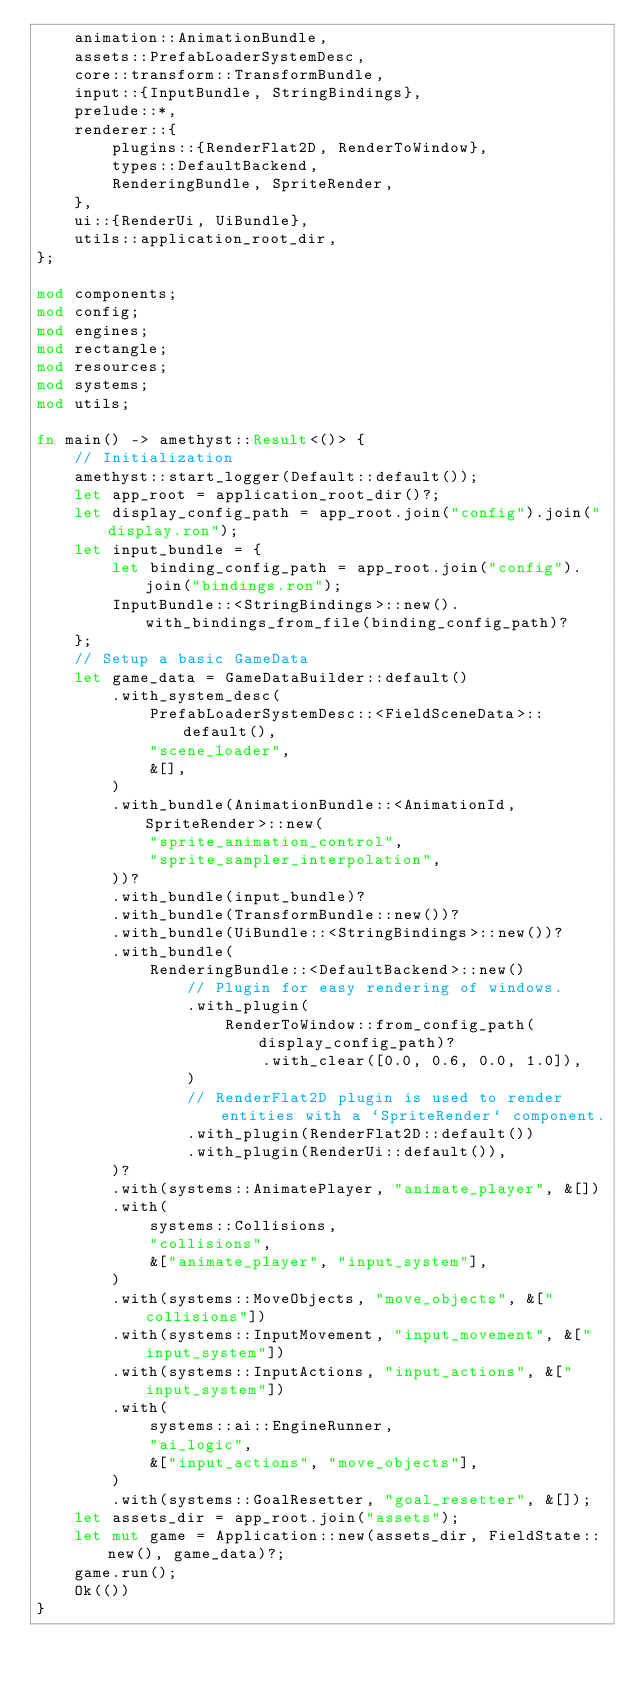Convert code to text. <code><loc_0><loc_0><loc_500><loc_500><_Rust_>    animation::AnimationBundle,
    assets::PrefabLoaderSystemDesc,
    core::transform::TransformBundle,
    input::{InputBundle, StringBindings},
    prelude::*,
    renderer::{
        plugins::{RenderFlat2D, RenderToWindow},
        types::DefaultBackend,
        RenderingBundle, SpriteRender,
    },
    ui::{RenderUi, UiBundle},
    utils::application_root_dir,
};

mod components;
mod config;
mod engines;
mod rectangle;
mod resources;
mod systems;
mod utils;

fn main() -> amethyst::Result<()> {
    // Initialization
    amethyst::start_logger(Default::default());
    let app_root = application_root_dir()?;
    let display_config_path = app_root.join("config").join("display.ron");
    let input_bundle = {
        let binding_config_path = app_root.join("config").join("bindings.ron");
        InputBundle::<StringBindings>::new().with_bindings_from_file(binding_config_path)?
    };
    // Setup a basic GameData
    let game_data = GameDataBuilder::default()
        .with_system_desc(
            PrefabLoaderSystemDesc::<FieldSceneData>::default(),
            "scene_loader",
            &[],
        )
        .with_bundle(AnimationBundle::<AnimationId, SpriteRender>::new(
            "sprite_animation_control",
            "sprite_sampler_interpolation",
        ))?
        .with_bundle(input_bundle)?
        .with_bundle(TransformBundle::new())?
        .with_bundle(UiBundle::<StringBindings>::new())?
        .with_bundle(
            RenderingBundle::<DefaultBackend>::new()
                // Plugin for easy rendering of windows.
                .with_plugin(
                    RenderToWindow::from_config_path(display_config_path)?
                        .with_clear([0.0, 0.6, 0.0, 1.0]),
                )
                // RenderFlat2D plugin is used to render entities with a `SpriteRender` component.
                .with_plugin(RenderFlat2D::default())
                .with_plugin(RenderUi::default()),
        )?
        .with(systems::AnimatePlayer, "animate_player", &[])
        .with(
            systems::Collisions,
            "collisions",
            &["animate_player", "input_system"],
        )
        .with(systems::MoveObjects, "move_objects", &["collisions"])
        .with(systems::InputMovement, "input_movement", &["input_system"])
        .with(systems::InputActions, "input_actions", &["input_system"])
        .with(
            systems::ai::EngineRunner,
            "ai_logic",
            &["input_actions", "move_objects"],
        )
        .with(systems::GoalResetter, "goal_resetter", &[]);
    let assets_dir = app_root.join("assets");
    let mut game = Application::new(assets_dir, FieldState::new(), game_data)?;
    game.run();
    Ok(())
}
</code> 